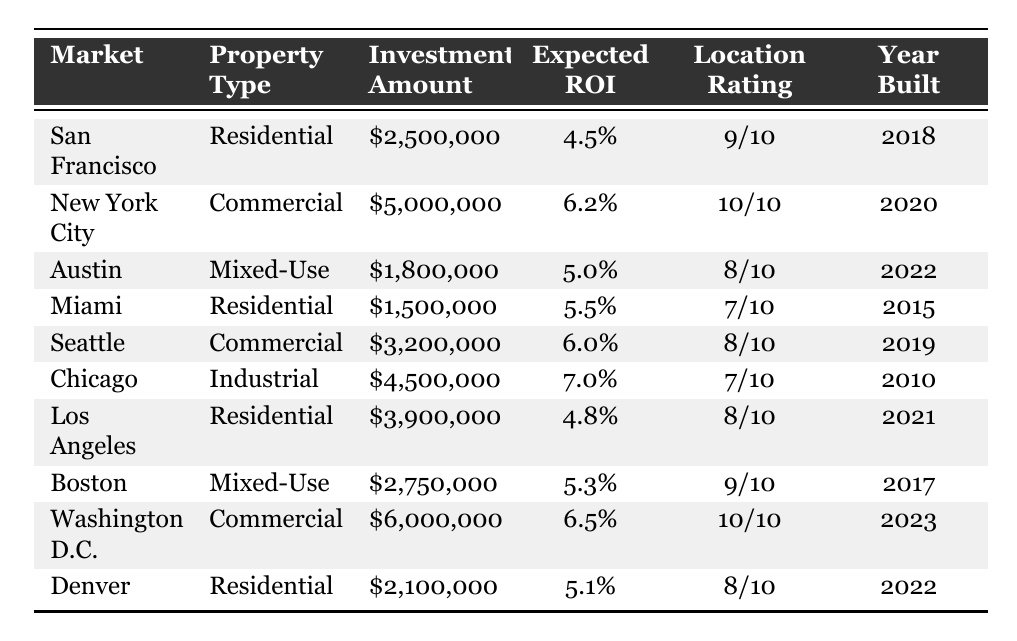What is the investment amount for the property in New York City? Referring to the table, the investment amount for the property listed under New York City is $5,000,000.
Answer: $5,000,000 Which market has the highest expected ROI? The expected ROIs for each market are compared: New York City (6.2%), Washington D.C. (6.5%), Chicago (7.0%), Seattle (6.0%), etc. The highest ROI is for Chicago at 7.0%.
Answer: Chicago What is the total investment amount across all markets? By summing the investment amounts listed for each market: $2,500,000 + $5,000,000 + $1,800,000 + $1,500,000 + $3,200,000 + $4,500,000 + $3,900,000 + $2,750,000 + $6,000,000 + $2,100,000 gives a total of $33,250,000.
Answer: $33,250,000 Are there more residential properties than commercial properties in the portfolio? Based on the table, there are four residential properties (San Francisco, Miami, Los Angeles, Denver) and three commercial properties (New York City, Seattle, Washington D.C.). Four is greater than three, confirming that there are more residential properties.
Answer: Yes What is the average location rating of the markets listed? The location ratings are converted to numerical values: 9, 10, 8, 7, 8, 7, 8, 9, 10, and 8, which sum up to 80. Dividing by the number of markets (10), gives an average of 8.0.
Answer: 8.0 Which market has the most recent year built? The year built for the properties is compared: the most recent year is 2023 for Washington D.C.
Answer: Washington D.C What is the difference in investment amount between the most and least expensive properties? The most expensive property is in New York City ($5,000,000) and the least expensive is in Miami ($1,500,000). The difference is $5,000,000 - $1,500,000 = $3,500,000.
Answer: $3,500,000 Is the expected ROI for residential properties generally higher than that for industrial properties? The expected ROIs for residential are 4.5%, 5.5%, 4.8%, and 5.1%, averaging approximately 5.0%. The industrial property's ROI is 7.0%. Since 5.0% < 7.0%, the statement is false.
Answer: No How many markets have a location rating of 10/10? Checking the table, both New York City and Washington D.C. have a location rating of 10/10, so the count is two.
Answer: 2 Calculate the total expected ROI from all markets to identify if it's above 5%. First convert the ROIs to decimals: 0.045, 0.062, 0.050, 0.055, 0.060, 0.070, 0.048, 0.053, 0.065, 0.051. The total expected ROI is 0.045 + 0.062 + 0.050 + 0.055 + 0.060 + 0.070 + 0.048 + 0.053 + 0.065 + 0.051 = 0.54. Dividing by 10 gives an average ROI of 0.054, or 5.4% which is above 5%.
Answer: Yes 